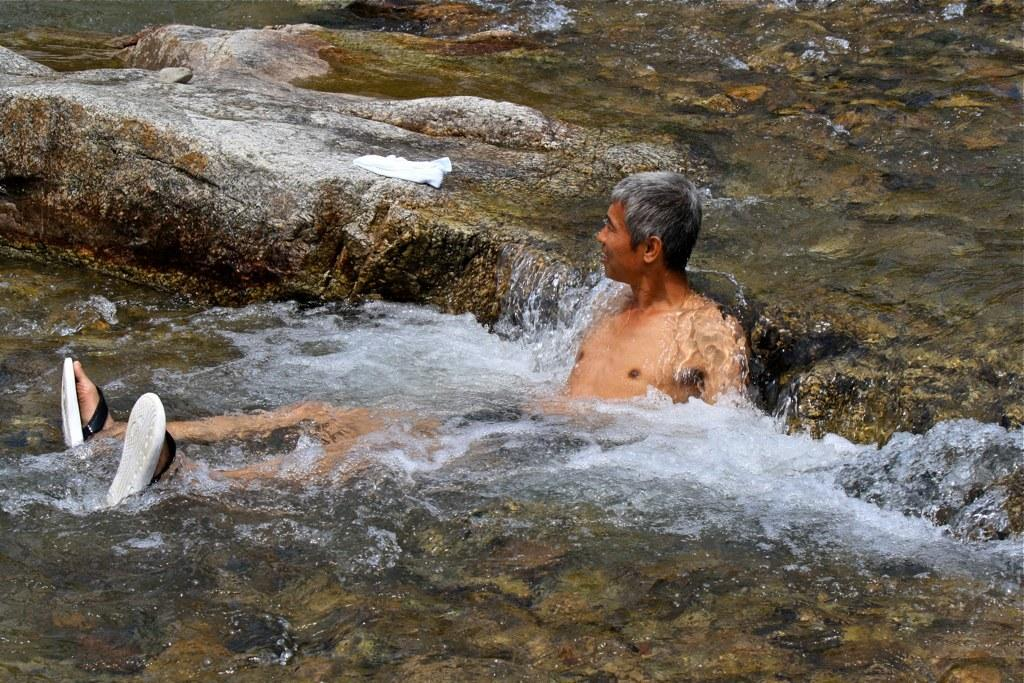What is the main subject of the image? There is a person in the image. What is the person wearing on their feet? The person is wearing footwear. Where is the person located in the image? The person is sitting in the water. What other objects can be seen in the image? There is a rock and some cloth visible in the image. What type of rod can be seen causing destruction to the person's throat in the image? There is no rod or destruction to the person's throat present in the image. 